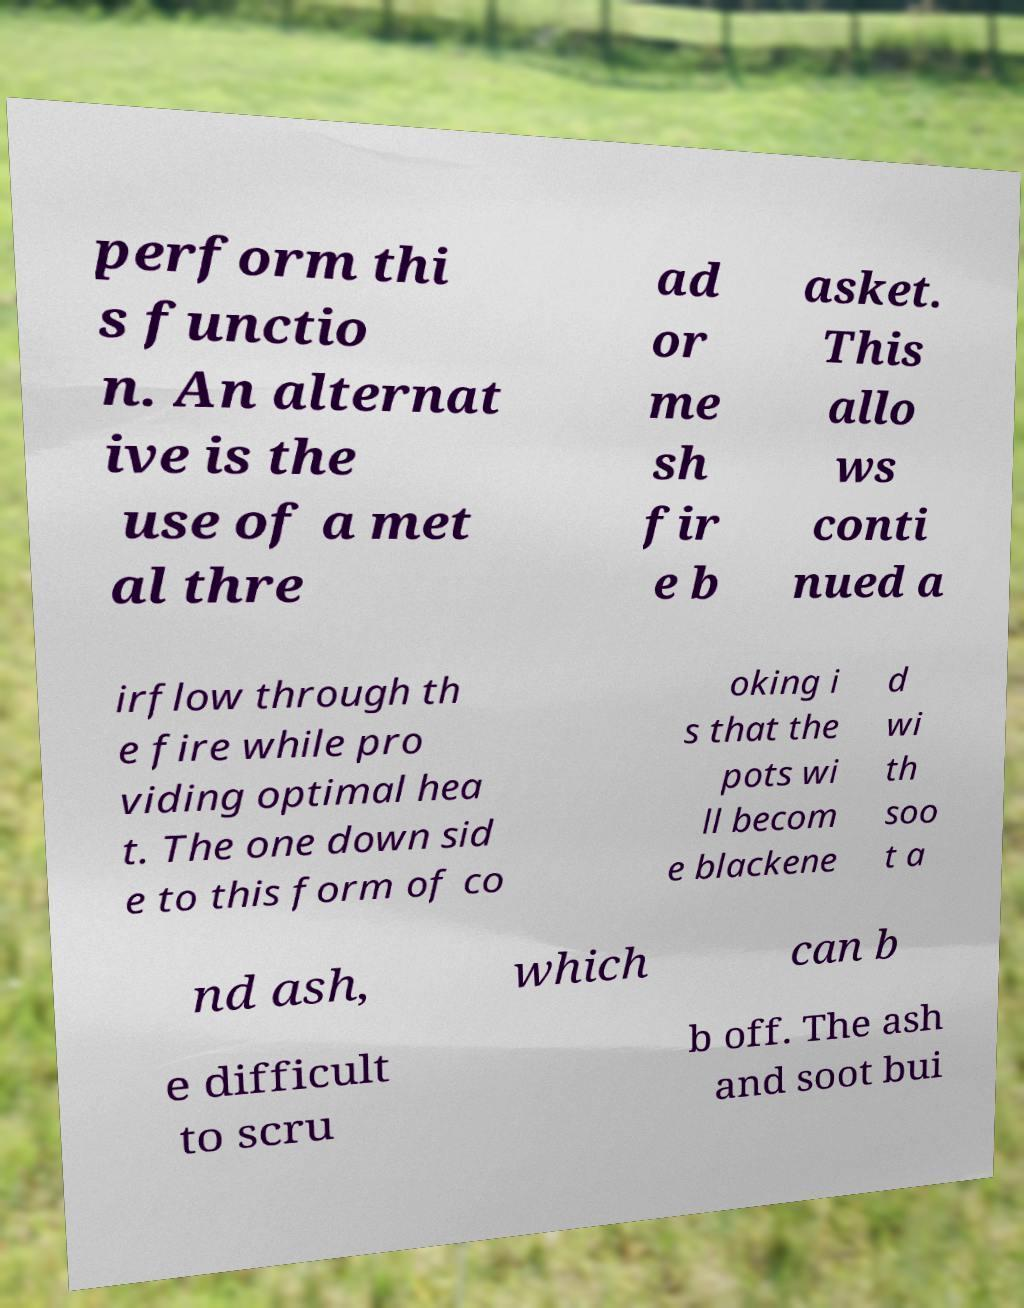Please identify and transcribe the text found in this image. perform thi s functio n. An alternat ive is the use of a met al thre ad or me sh fir e b asket. This allo ws conti nued a irflow through th e fire while pro viding optimal hea t. The one down sid e to this form of co oking i s that the pots wi ll becom e blackene d wi th soo t a nd ash, which can b e difficult to scru b off. The ash and soot bui 